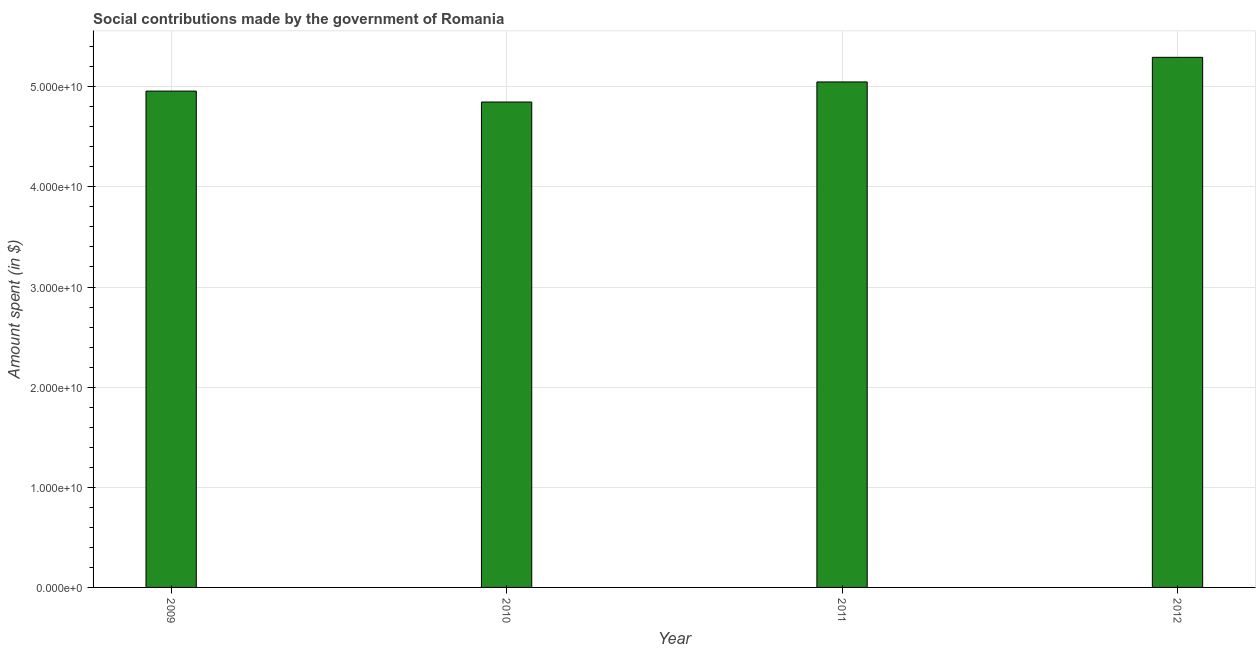Does the graph contain any zero values?
Offer a very short reply. No. What is the title of the graph?
Give a very brief answer. Social contributions made by the government of Romania. What is the label or title of the Y-axis?
Provide a succinct answer. Amount spent (in $). What is the amount spent in making social contributions in 2011?
Provide a short and direct response. 5.05e+1. Across all years, what is the maximum amount spent in making social contributions?
Ensure brevity in your answer.  5.29e+1. Across all years, what is the minimum amount spent in making social contributions?
Offer a very short reply. 4.85e+1. In which year was the amount spent in making social contributions minimum?
Your answer should be compact. 2010. What is the sum of the amount spent in making social contributions?
Your answer should be compact. 2.01e+11. What is the difference between the amount spent in making social contributions in 2009 and 2012?
Keep it short and to the point. -3.37e+09. What is the average amount spent in making social contributions per year?
Provide a short and direct response. 5.04e+1. What is the median amount spent in making social contributions?
Your answer should be very brief. 5.00e+1. In how many years, is the amount spent in making social contributions greater than 34000000000 $?
Give a very brief answer. 4. Do a majority of the years between 2010 and 2012 (inclusive) have amount spent in making social contributions greater than 4000000000 $?
Your answer should be compact. Yes. What is the ratio of the amount spent in making social contributions in 2011 to that in 2012?
Make the answer very short. 0.95. Is the difference between the amount spent in making social contributions in 2009 and 2012 greater than the difference between any two years?
Provide a short and direct response. No. What is the difference between the highest and the second highest amount spent in making social contributions?
Provide a short and direct response. 2.46e+09. Is the sum of the amount spent in making social contributions in 2009 and 2011 greater than the maximum amount spent in making social contributions across all years?
Ensure brevity in your answer.  Yes. What is the difference between the highest and the lowest amount spent in making social contributions?
Give a very brief answer. 4.46e+09. How many bars are there?
Make the answer very short. 4. Are all the bars in the graph horizontal?
Offer a very short reply. No. How many years are there in the graph?
Your answer should be very brief. 4. What is the difference between two consecutive major ticks on the Y-axis?
Offer a terse response. 1.00e+1. What is the Amount spent (in $) of 2009?
Provide a succinct answer. 4.96e+1. What is the Amount spent (in $) in 2010?
Offer a terse response. 4.85e+1. What is the Amount spent (in $) of 2011?
Ensure brevity in your answer.  5.05e+1. What is the Amount spent (in $) of 2012?
Offer a very short reply. 5.29e+1. What is the difference between the Amount spent (in $) in 2009 and 2010?
Your answer should be very brief. 1.09e+09. What is the difference between the Amount spent (in $) in 2009 and 2011?
Offer a terse response. -9.14e+08. What is the difference between the Amount spent (in $) in 2009 and 2012?
Your response must be concise. -3.37e+09. What is the difference between the Amount spent (in $) in 2010 and 2011?
Keep it short and to the point. -2.01e+09. What is the difference between the Amount spent (in $) in 2010 and 2012?
Offer a terse response. -4.46e+09. What is the difference between the Amount spent (in $) in 2011 and 2012?
Offer a very short reply. -2.46e+09. What is the ratio of the Amount spent (in $) in 2009 to that in 2010?
Give a very brief answer. 1.02. What is the ratio of the Amount spent (in $) in 2009 to that in 2012?
Provide a succinct answer. 0.94. What is the ratio of the Amount spent (in $) in 2010 to that in 2011?
Make the answer very short. 0.96. What is the ratio of the Amount spent (in $) in 2010 to that in 2012?
Provide a short and direct response. 0.92. What is the ratio of the Amount spent (in $) in 2011 to that in 2012?
Offer a very short reply. 0.95. 